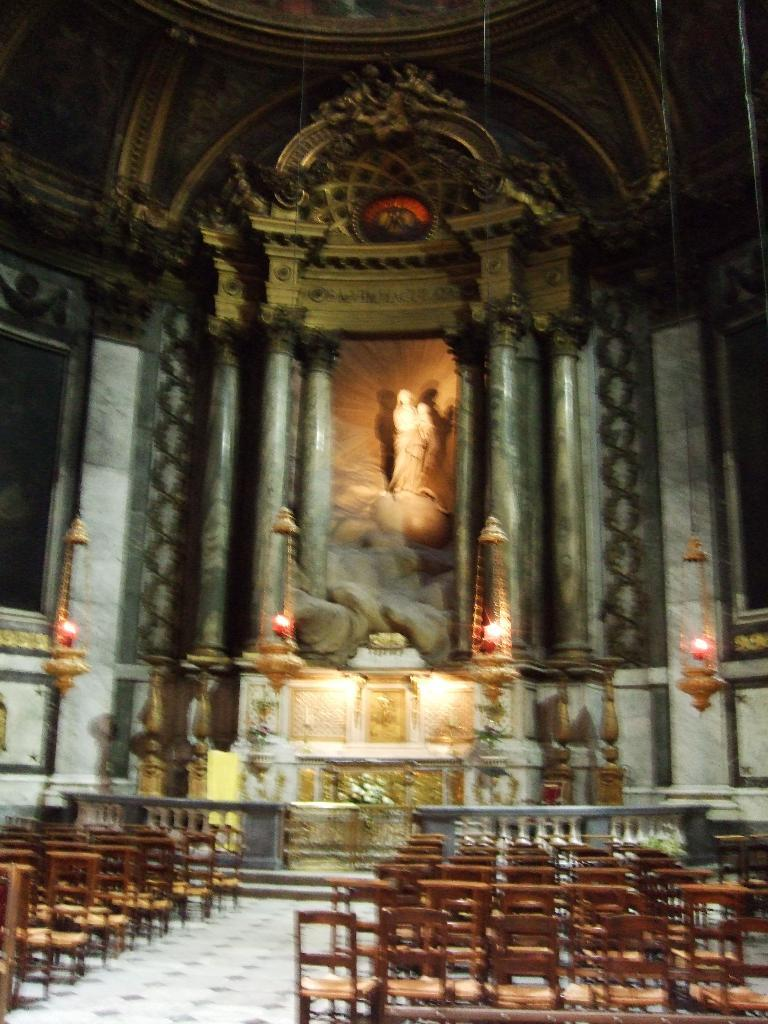What type of building is shown in the image? The image is an inside view of a church. How are the chairs arranged in the church? Chairs are arranged in the church. What can be seen in the middle of the image? There is a statue in the middle of the image. How does the church increase its membership in the image? The image does not show any information about the church's membership or how it might increase. --- Facts: 1. There is a person sitting on a bench in the image. 2. The person is reading a book. 3. There is a tree behind the bench. 4. The sky is visible in the image. Absurd Topics: dance, parrot, ticket Conversation: What is the person in the image doing? The person is sitting on a bench in the image. What activity is the person engaged in while sitting on the bench? The person is reading a book. What can be seen behind the bench in the image? There is a tree behind the bench. What is visible in the background of the image? The sky is visible in the image. Reasoning: Let's think step by step in order to produce the conversation. We start by identifying the main subject in the image, which is the person sitting on the bench. Then, we describe the activity the person is engaged in, which is reading a book. Next, we mention the tree that is present behind the bench. Finally, we acknowledge the presence of the sky in the background of the image. Each question is designed to elicit a specific detail about the image that is known from the provided facts. Absurd Question/Answer: What type of dance is the person performing in the image? There is no indication in the image that the person is dancing; they are sitting on a bench and reading a book. 